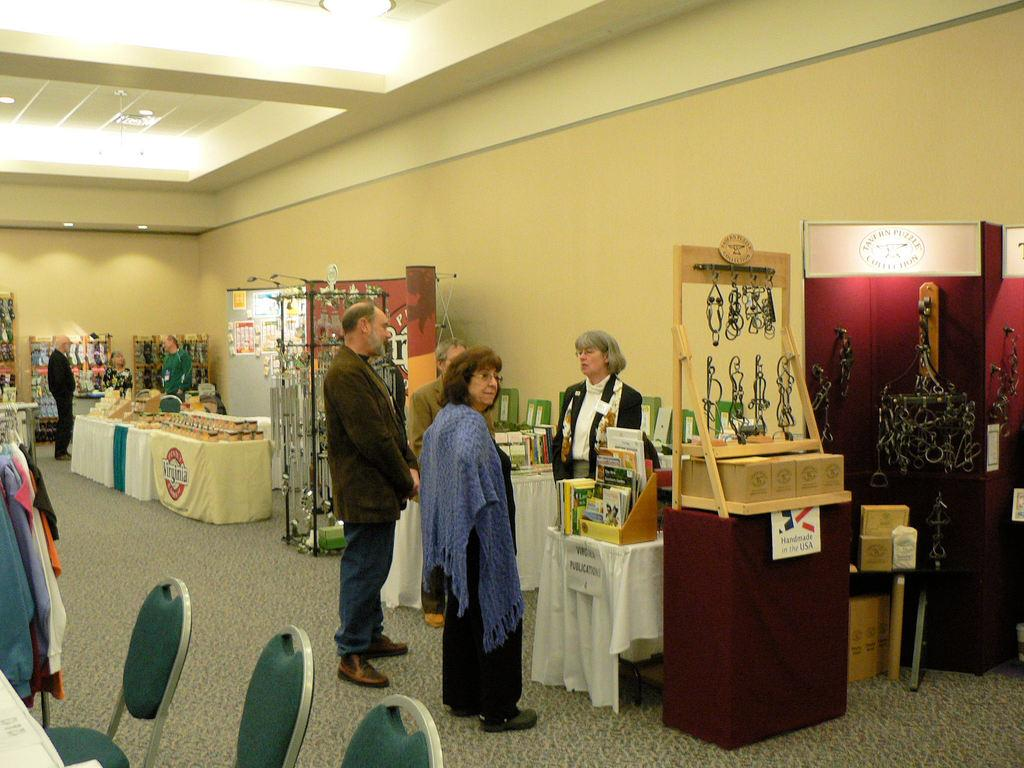What are the people in the image doing on the floor? The facts do not specify what the people are doing on the floor. What type of furniture is present in the image? There are tables and chairs in the image. What else can be seen in the image besides people and furniture? Clothes and objects are visible in the image. What can be seen in the background of the image? There is a wall and lights in the background of the image. How does the aftermath of the event affect the people in the image? There is no event mentioned in the facts, so it is impossible to determine the aftermath and its effect on the people in the image. 